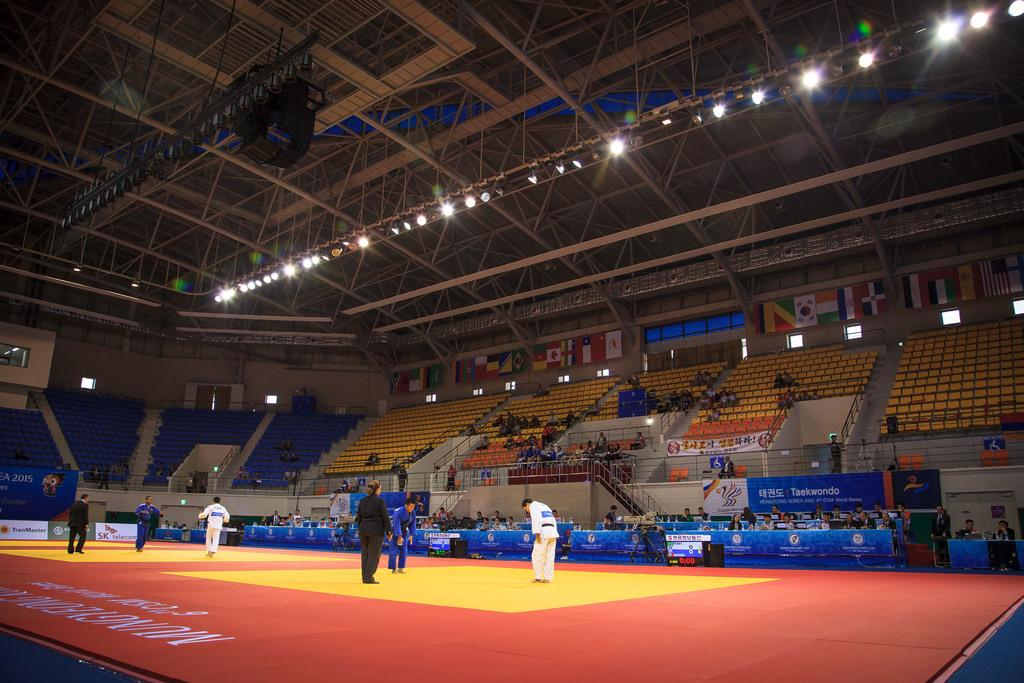<image>
Present a compact description of the photo's key features. A sporting even which has an advert for TransMaster in the background. 